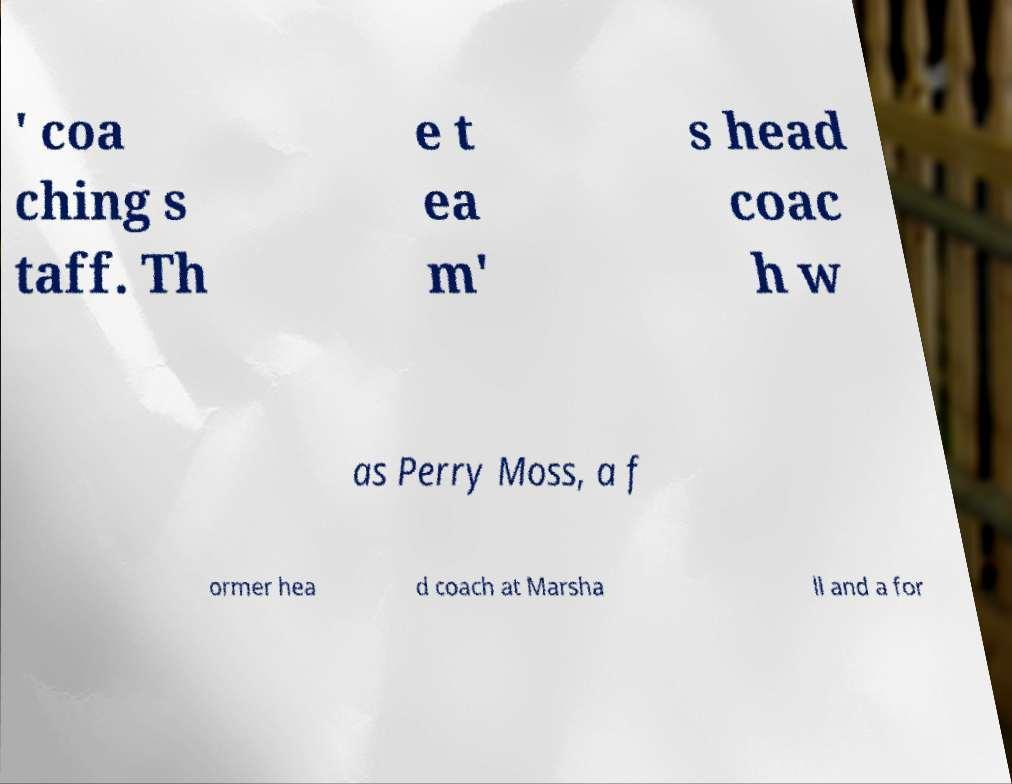Can you accurately transcribe the text from the provided image for me? ' coa ching s taff. Th e t ea m' s head coac h w as Perry Moss, a f ormer hea d coach at Marsha ll and a for 